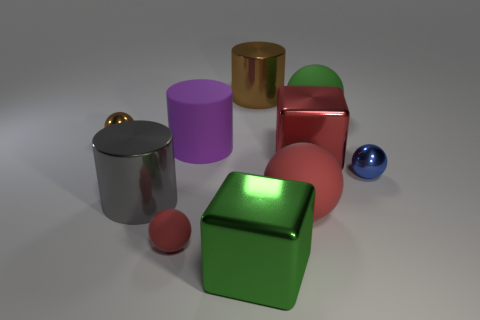There is a brown object in front of the green matte ball; is it the same size as the large green shiny thing?
Ensure brevity in your answer.  No. The rubber thing that is right of the large sphere that is to the left of the green object behind the brown ball is what color?
Your response must be concise. Green. The matte cylinder is what color?
Make the answer very short. Purple. Is the big matte cylinder the same color as the tiny rubber thing?
Give a very brief answer. No. Is the small thing on the right side of the large brown cylinder made of the same material as the brown object behind the brown metallic ball?
Ensure brevity in your answer.  Yes. What material is the large gray thing that is the same shape as the big purple rubber thing?
Make the answer very short. Metal. Is the small red ball made of the same material as the large red block?
Ensure brevity in your answer.  No. There is a big cube in front of the cylinder in front of the small blue sphere; what is its color?
Ensure brevity in your answer.  Green. There is a brown cylinder that is made of the same material as the blue sphere; what size is it?
Keep it short and to the point. Large. What number of other gray shiny things have the same shape as the gray object?
Your response must be concise. 0. 